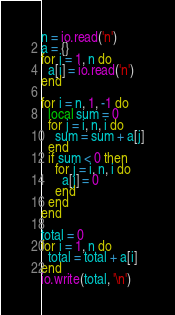<code> <loc_0><loc_0><loc_500><loc_500><_Lua_>n = io.read('n')
a = {}
for i = 1, n do
  a[i] = io.read('n')
end

for i = n, 1, -1 do
  local sum = 0
  for j = i, n, i do
    sum = sum + a[j]
  end
  if sum < 0 then
    for j = i, n, i do
      a[j] = 0
    end
  end
end

total = 0
for i = 1, n do
  total = total + a[i]
end
io.write(total, '\n')
</code> 